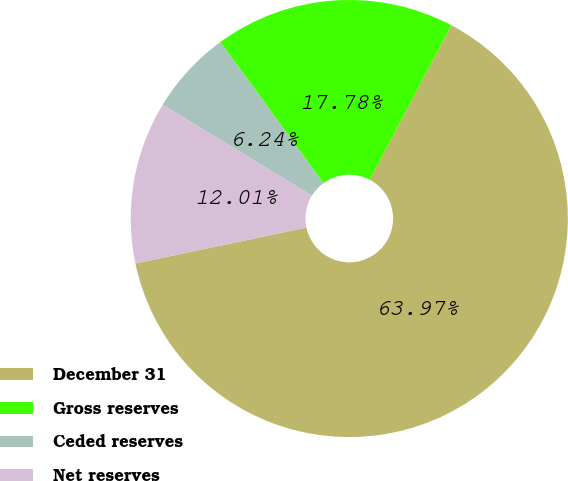Convert chart. <chart><loc_0><loc_0><loc_500><loc_500><pie_chart><fcel>December 31<fcel>Gross reserves<fcel>Ceded reserves<fcel>Net reserves<nl><fcel>63.96%<fcel>17.78%<fcel>6.24%<fcel>12.01%<nl></chart> 